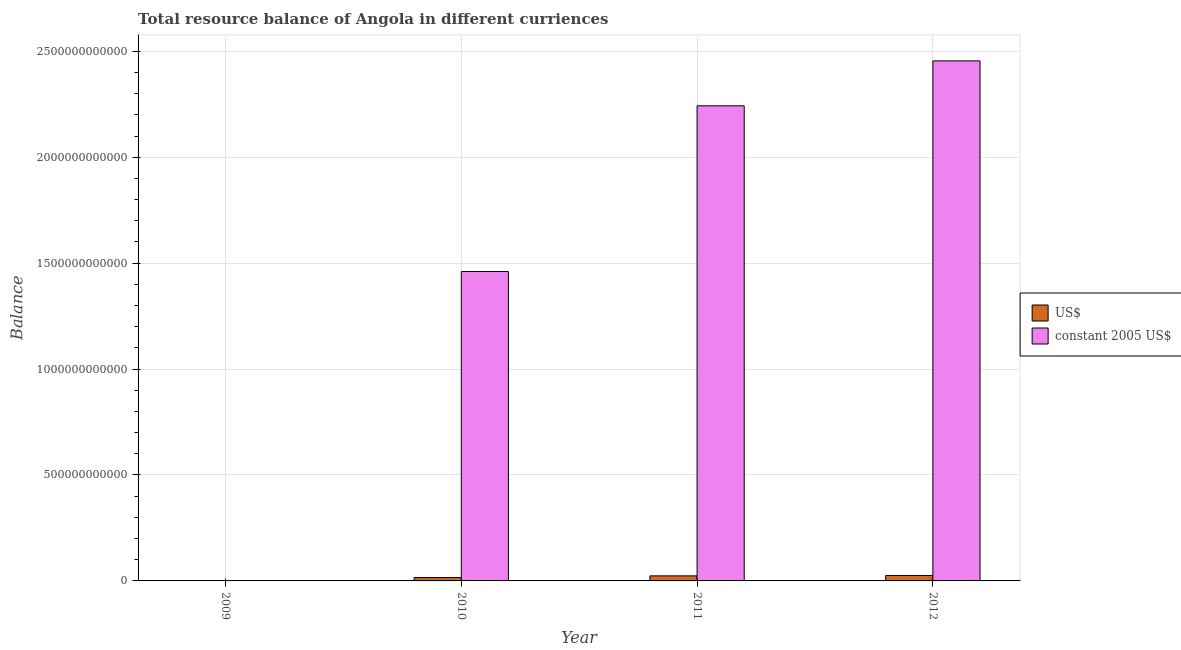How many different coloured bars are there?
Provide a succinct answer. 2. Are the number of bars per tick equal to the number of legend labels?
Your answer should be very brief. No. How many bars are there on the 4th tick from the right?
Provide a succinct answer. 0. In how many cases, is the number of bars for a given year not equal to the number of legend labels?
Offer a terse response. 1. What is the resource balance in us$ in 2011?
Offer a very short reply. 2.39e+1. Across all years, what is the maximum resource balance in us$?
Offer a terse response. 2.57e+1. In which year was the resource balance in us$ maximum?
Provide a short and direct response. 2012. What is the total resource balance in constant us$ in the graph?
Make the answer very short. 6.16e+12. What is the difference between the resource balance in us$ in 2010 and that in 2011?
Keep it short and to the point. -7.98e+09. What is the difference between the resource balance in us$ in 2012 and the resource balance in constant us$ in 2010?
Provide a succinct answer. 9.84e+09. What is the average resource balance in constant us$ per year?
Keep it short and to the point. 1.54e+12. In the year 2012, what is the difference between the resource balance in constant us$ and resource balance in us$?
Give a very brief answer. 0. In how many years, is the resource balance in constant us$ greater than 700000000000 units?
Make the answer very short. 3. What is the ratio of the resource balance in us$ in 2010 to that in 2011?
Offer a very short reply. 0.67. What is the difference between the highest and the second highest resource balance in constant us$?
Your answer should be very brief. 2.12e+11. What is the difference between the highest and the lowest resource balance in us$?
Provide a succinct answer. 2.57e+1. How many bars are there?
Provide a succinct answer. 6. What is the difference between two consecutive major ticks on the Y-axis?
Offer a very short reply. 5.00e+11. Does the graph contain any zero values?
Your response must be concise. Yes. Does the graph contain grids?
Provide a short and direct response. Yes. What is the title of the graph?
Your response must be concise. Total resource balance of Angola in different curriences. Does "Mineral" appear as one of the legend labels in the graph?
Offer a terse response. No. What is the label or title of the X-axis?
Your response must be concise. Year. What is the label or title of the Y-axis?
Offer a very short reply. Balance. What is the Balance of US$ in 2009?
Ensure brevity in your answer.  0. What is the Balance of constant 2005 US$ in 2009?
Your answer should be very brief. 0. What is the Balance in US$ in 2010?
Offer a very short reply. 1.59e+1. What is the Balance in constant 2005 US$ in 2010?
Give a very brief answer. 1.46e+12. What is the Balance in US$ in 2011?
Give a very brief answer. 2.39e+1. What is the Balance of constant 2005 US$ in 2011?
Provide a succinct answer. 2.24e+12. What is the Balance of US$ in 2012?
Offer a terse response. 2.57e+1. What is the Balance of constant 2005 US$ in 2012?
Your response must be concise. 2.45e+12. Across all years, what is the maximum Balance in US$?
Provide a succinct answer. 2.57e+1. Across all years, what is the maximum Balance in constant 2005 US$?
Ensure brevity in your answer.  2.45e+12. What is the total Balance of US$ in the graph?
Make the answer very short. 6.55e+1. What is the total Balance of constant 2005 US$ in the graph?
Offer a very short reply. 6.16e+12. What is the difference between the Balance in US$ in 2010 and that in 2011?
Provide a short and direct response. -7.98e+09. What is the difference between the Balance of constant 2005 US$ in 2010 and that in 2011?
Ensure brevity in your answer.  -7.82e+11. What is the difference between the Balance in US$ in 2010 and that in 2012?
Your answer should be compact. -9.84e+09. What is the difference between the Balance of constant 2005 US$ in 2010 and that in 2012?
Provide a short and direct response. -9.94e+11. What is the difference between the Balance of US$ in 2011 and that in 2012?
Your answer should be compact. -1.85e+09. What is the difference between the Balance of constant 2005 US$ in 2011 and that in 2012?
Ensure brevity in your answer.  -2.12e+11. What is the difference between the Balance of US$ in 2010 and the Balance of constant 2005 US$ in 2011?
Your response must be concise. -2.23e+12. What is the difference between the Balance in US$ in 2010 and the Balance in constant 2005 US$ in 2012?
Ensure brevity in your answer.  -2.44e+12. What is the difference between the Balance in US$ in 2011 and the Balance in constant 2005 US$ in 2012?
Give a very brief answer. -2.43e+12. What is the average Balance of US$ per year?
Offer a terse response. 1.64e+1. What is the average Balance in constant 2005 US$ per year?
Offer a very short reply. 1.54e+12. In the year 2010, what is the difference between the Balance of US$ and Balance of constant 2005 US$?
Make the answer very short. -1.44e+12. In the year 2011, what is the difference between the Balance in US$ and Balance in constant 2005 US$?
Keep it short and to the point. -2.22e+12. In the year 2012, what is the difference between the Balance of US$ and Balance of constant 2005 US$?
Provide a succinct answer. -2.43e+12. What is the ratio of the Balance in US$ in 2010 to that in 2011?
Provide a short and direct response. 0.67. What is the ratio of the Balance of constant 2005 US$ in 2010 to that in 2011?
Offer a terse response. 0.65. What is the ratio of the Balance in US$ in 2010 to that in 2012?
Provide a short and direct response. 0.62. What is the ratio of the Balance of constant 2005 US$ in 2010 to that in 2012?
Give a very brief answer. 0.59. What is the ratio of the Balance in US$ in 2011 to that in 2012?
Offer a very short reply. 0.93. What is the ratio of the Balance of constant 2005 US$ in 2011 to that in 2012?
Make the answer very short. 0.91. What is the difference between the highest and the second highest Balance of US$?
Your answer should be compact. 1.85e+09. What is the difference between the highest and the second highest Balance in constant 2005 US$?
Ensure brevity in your answer.  2.12e+11. What is the difference between the highest and the lowest Balance of US$?
Make the answer very short. 2.57e+1. What is the difference between the highest and the lowest Balance of constant 2005 US$?
Offer a terse response. 2.45e+12. 